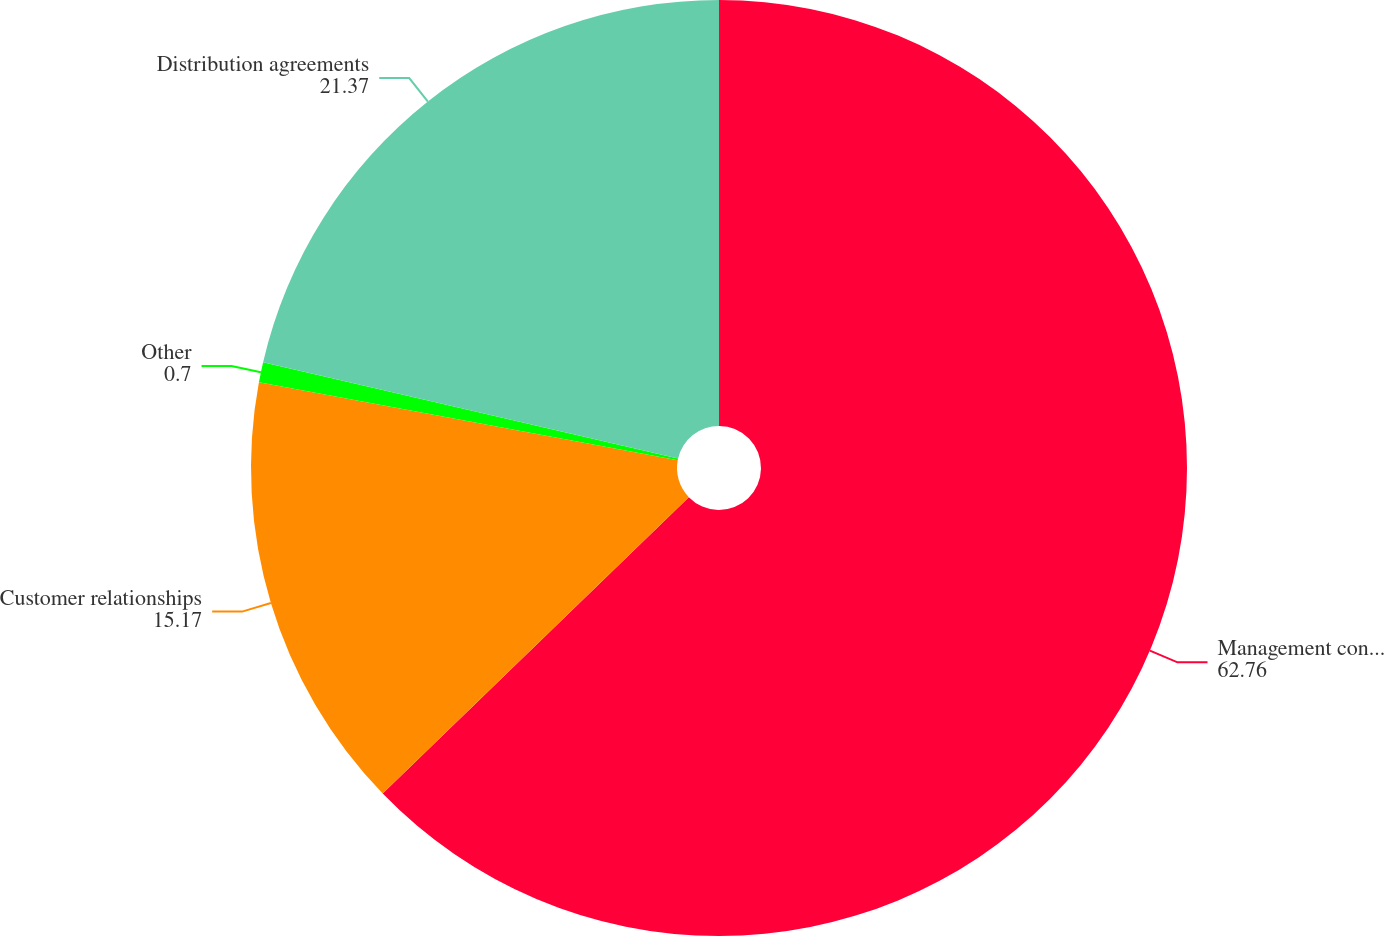Convert chart to OTSL. <chart><loc_0><loc_0><loc_500><loc_500><pie_chart><fcel>Management contracts -<fcel>Customer relationships<fcel>Other<fcel>Distribution agreements<nl><fcel>62.76%<fcel>15.17%<fcel>0.7%<fcel>21.37%<nl></chart> 